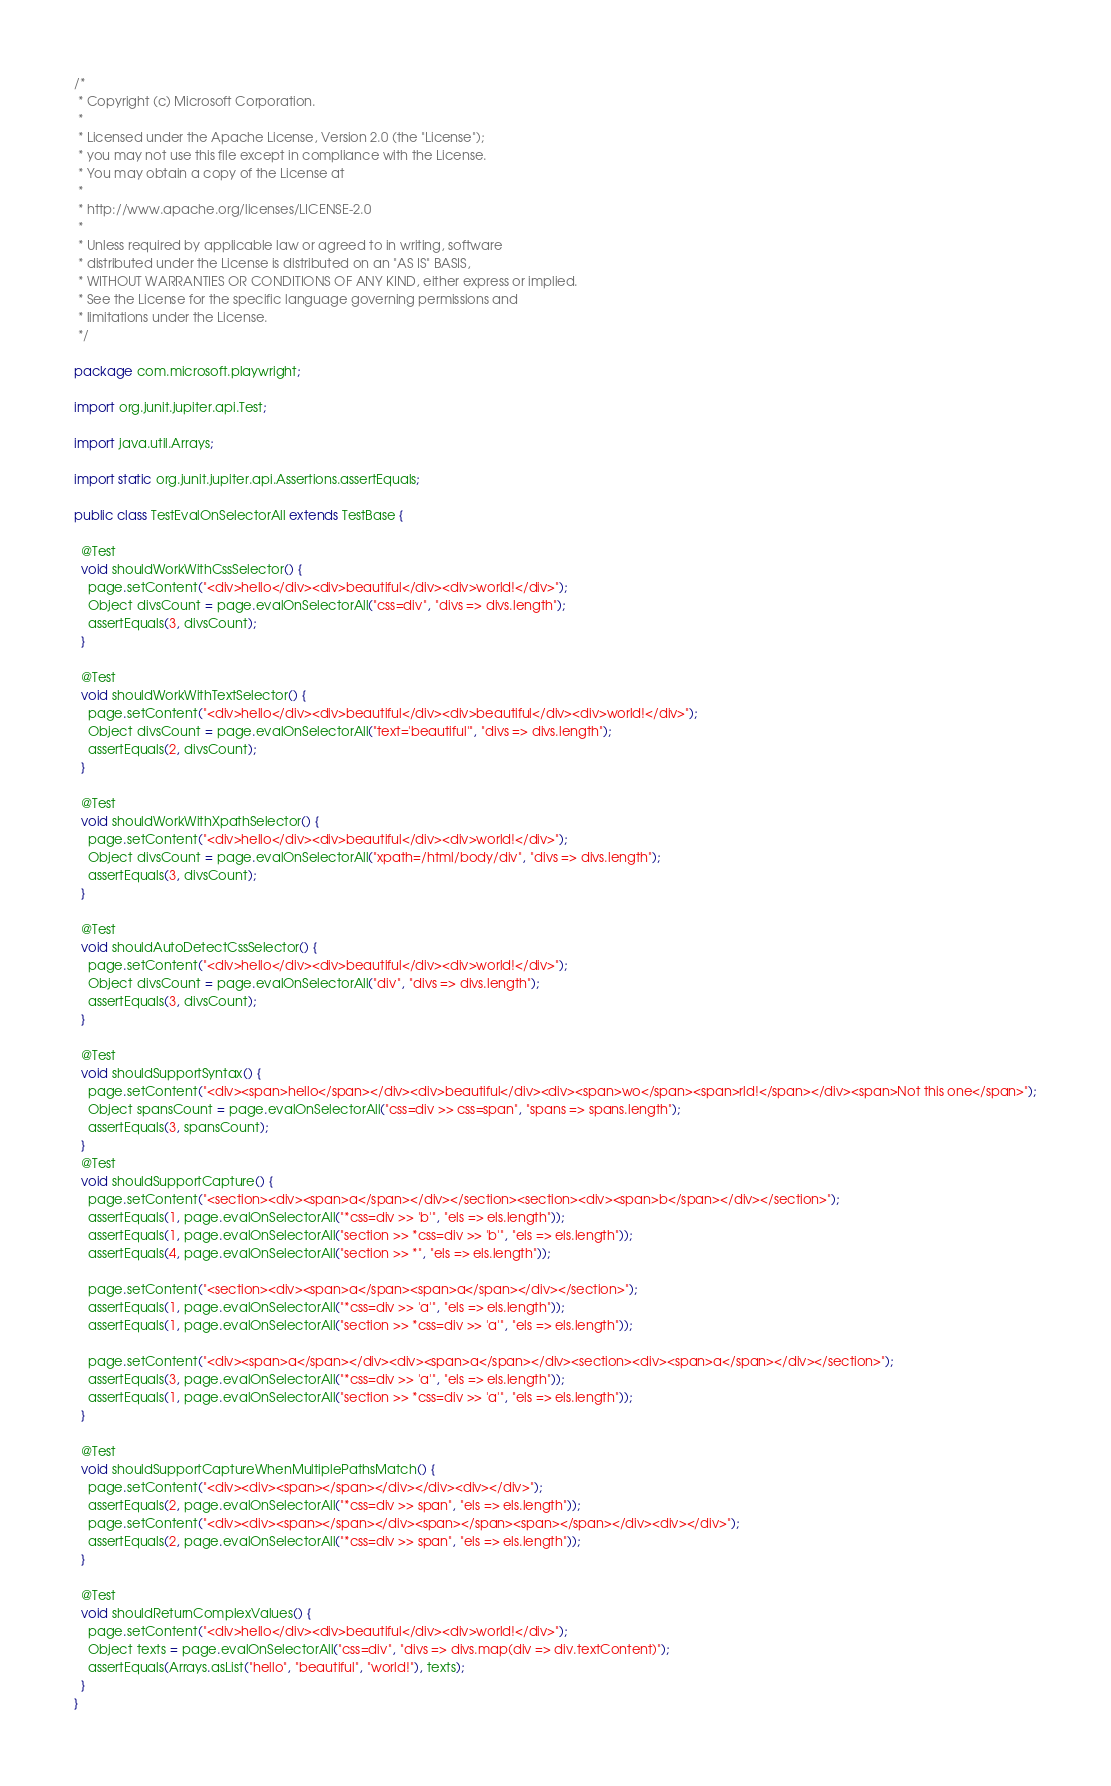Convert code to text. <code><loc_0><loc_0><loc_500><loc_500><_Java_>/*
 * Copyright (c) Microsoft Corporation.
 *
 * Licensed under the Apache License, Version 2.0 (the "License");
 * you may not use this file except in compliance with the License.
 * You may obtain a copy of the License at
 *
 * http://www.apache.org/licenses/LICENSE-2.0
 *
 * Unless required by applicable law or agreed to in writing, software
 * distributed under the License is distributed on an "AS IS" BASIS,
 * WITHOUT WARRANTIES OR CONDITIONS OF ANY KIND, either express or implied.
 * See the License for the specific language governing permissions and
 * limitations under the License.
 */

package com.microsoft.playwright;

import org.junit.jupiter.api.Test;

import java.util.Arrays;

import static org.junit.jupiter.api.Assertions.assertEquals;

public class TestEvalOnSelectorAll extends TestBase {

  @Test
  void shouldWorkWithCssSelector() {
    page.setContent("<div>hello</div><div>beautiful</div><div>world!</div>");
    Object divsCount = page.evalOnSelectorAll("css=div", "divs => divs.length");
    assertEquals(3, divsCount);
  }

  @Test
  void shouldWorkWithTextSelector() {
    page.setContent("<div>hello</div><div>beautiful</div><div>beautiful</div><div>world!</div>");
    Object divsCount = page.evalOnSelectorAll("text='beautiful'", "divs => divs.length");
    assertEquals(2, divsCount);
  }

  @Test
  void shouldWorkWithXpathSelector() {
    page.setContent("<div>hello</div><div>beautiful</div><div>world!</div>");
    Object divsCount = page.evalOnSelectorAll("xpath=/html/body/div", "divs => divs.length");
    assertEquals(3, divsCount);
  }

  @Test
  void shouldAutoDetectCssSelector() {
    page.setContent("<div>hello</div><div>beautiful</div><div>world!</div>");
    Object divsCount = page.evalOnSelectorAll("div", "divs => divs.length");
    assertEquals(3, divsCount);
  }

  @Test
  void shouldSupportSyntax() {
    page.setContent("<div><span>hello</span></div><div>beautiful</div><div><span>wo</span><span>rld!</span></div><span>Not this one</span>");
    Object spansCount = page.evalOnSelectorAll("css=div >> css=span", "spans => spans.length");
    assertEquals(3, spansCount);
  }
  @Test
  void shouldSupportCapture() {
    page.setContent("<section><div><span>a</span></div></section><section><div><span>b</span></div></section>");
    assertEquals(1, page.evalOnSelectorAll("*css=div >> 'b'", "els => els.length"));
    assertEquals(1, page.evalOnSelectorAll("section >> *css=div >> 'b'", "els => els.length"));
    assertEquals(4, page.evalOnSelectorAll("section >> *", "els => els.length"));

    page.setContent("<section><div><span>a</span><span>a</span></div></section>");
    assertEquals(1, page.evalOnSelectorAll("*css=div >> 'a'", "els => els.length"));
    assertEquals(1, page.evalOnSelectorAll("section >> *css=div >> 'a'", "els => els.length"));

    page.setContent("<div><span>a</span></div><div><span>a</span></div><section><div><span>a</span></div></section>");
    assertEquals(3, page.evalOnSelectorAll("*css=div >> 'a'", "els => els.length"));
    assertEquals(1, page.evalOnSelectorAll("section >> *css=div >> 'a'", "els => els.length"));
  }

  @Test
  void shouldSupportCaptureWhenMultiplePathsMatch() {
    page.setContent("<div><div><span></span></div></div><div></div>");
    assertEquals(2, page.evalOnSelectorAll("*css=div >> span", "els => els.length"));
    page.setContent("<div><div><span></span></div><span></span><span></span></div><div></div>");
    assertEquals(2, page.evalOnSelectorAll("*css=div >> span", "els => els.length"));
  }

  @Test
  void shouldReturnComplexValues() {
    page.setContent("<div>hello</div><div>beautiful</div><div>world!</div>");
    Object texts = page.evalOnSelectorAll("css=div", "divs => divs.map(div => div.textContent)");
    assertEquals(Arrays.asList("hello", "beautiful", "world!"), texts);
  }
}
</code> 